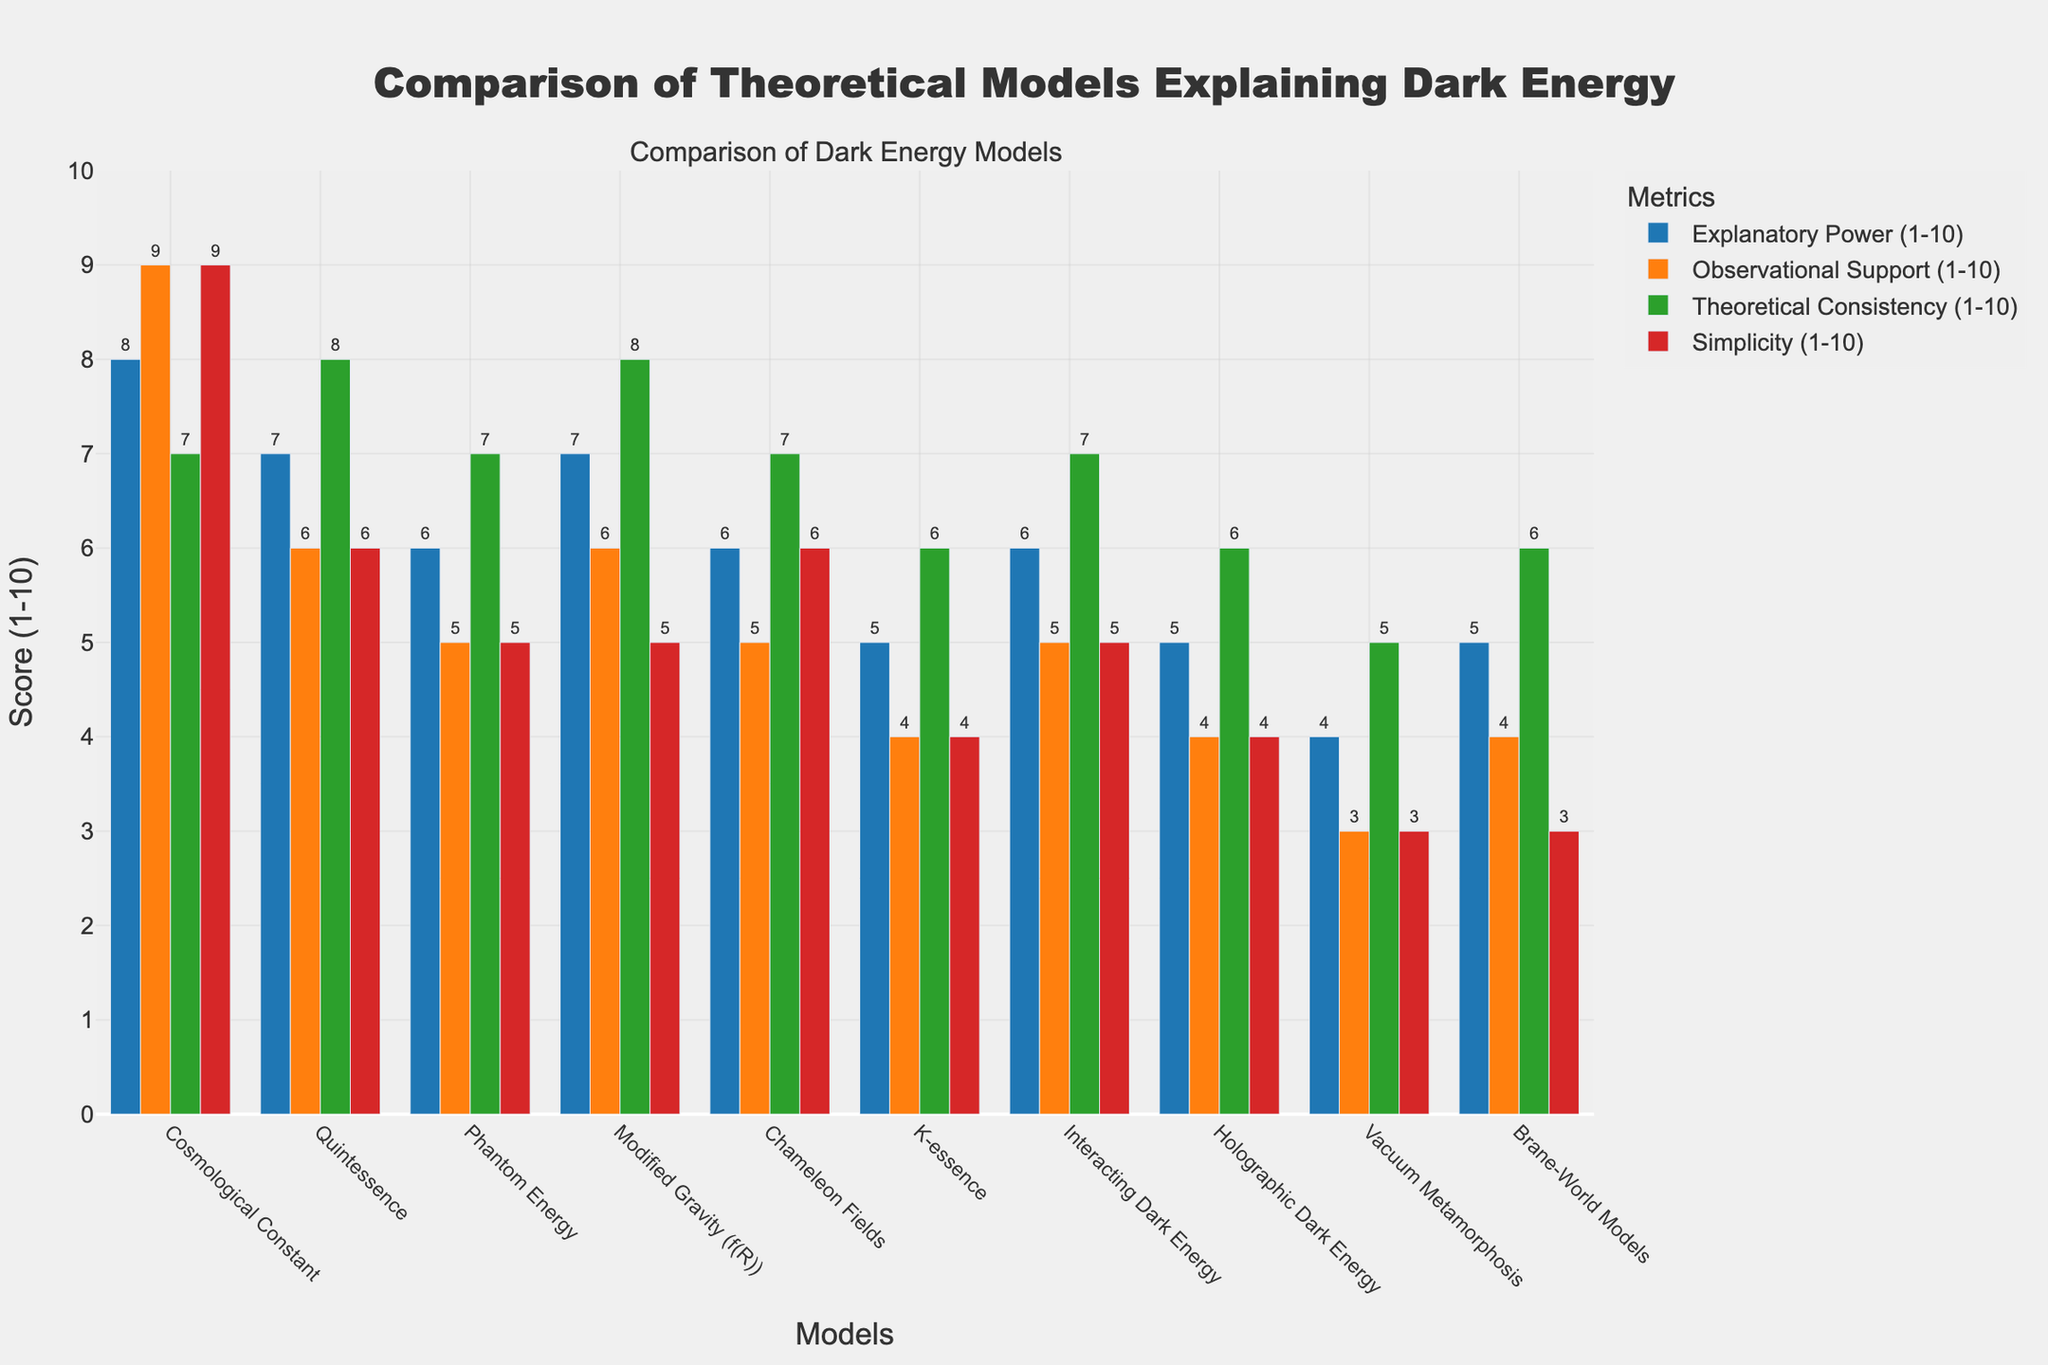Which model has the highest observational support? By looking at the bar heights for the "Observational Support" metric, we see that the "Cosmological Constant" has the highest value, indicated by the tallest bar in this category.
Answer: Cosmological Constant Which model scores below 5 in both simplicity and explanatory power? By comparing the heights of the bars in both "Simplicity" and "Explanatory Power", we find that "Vacuum Metamorphosis" scores 4 in simplicity and 4 in explanatory power, both below 5.
Answer: Vacuum Metamorphosis What is the total score of the "Quintessence" model across all metrics? The respective scores for "Quintessence" are: Explanatory Power = 7, Observational Support = 6, Theoretical Consistency = 8, and Simplicity = 6. Summing these values, we get 7 + 6 + 8 + 6 = 27.
Answer: 27 Which model has the lowest score in theoretical consistency and what is the value? By examining the "Theoretical Consistency" bar heights, "Vacuum Metamorphosis" has the lowest score with a bar height corresponding to 5.
Answer: Vacuum Metamorphosis, 5 Which model is rated the simplest, and what is its score? In the "Simplicity" category, the "Cosmological Constant" has the highest bar, indicating a score of 9, making it the simplest model.
Answer: Cosmological Constant, 9 